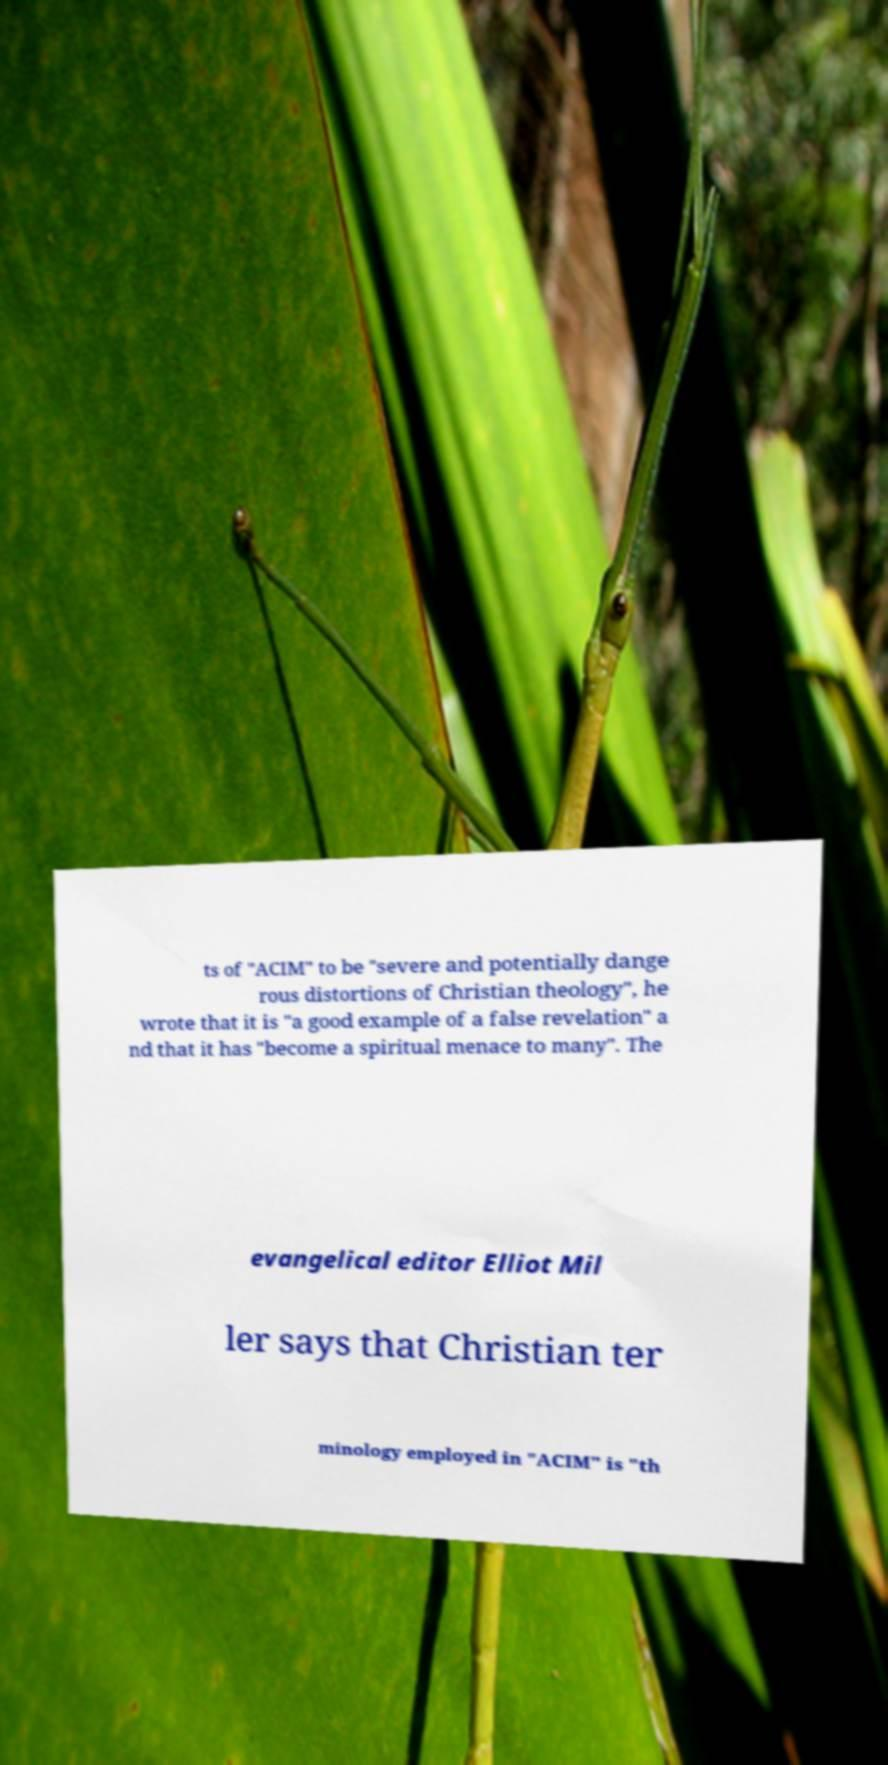For documentation purposes, I need the text within this image transcribed. Could you provide that? ts of "ACIM" to be "severe and potentially dange rous distortions of Christian theology", he wrote that it is "a good example of a false revelation" a nd that it has "become a spiritual menace to many". The evangelical editor Elliot Mil ler says that Christian ter minology employed in "ACIM" is "th 